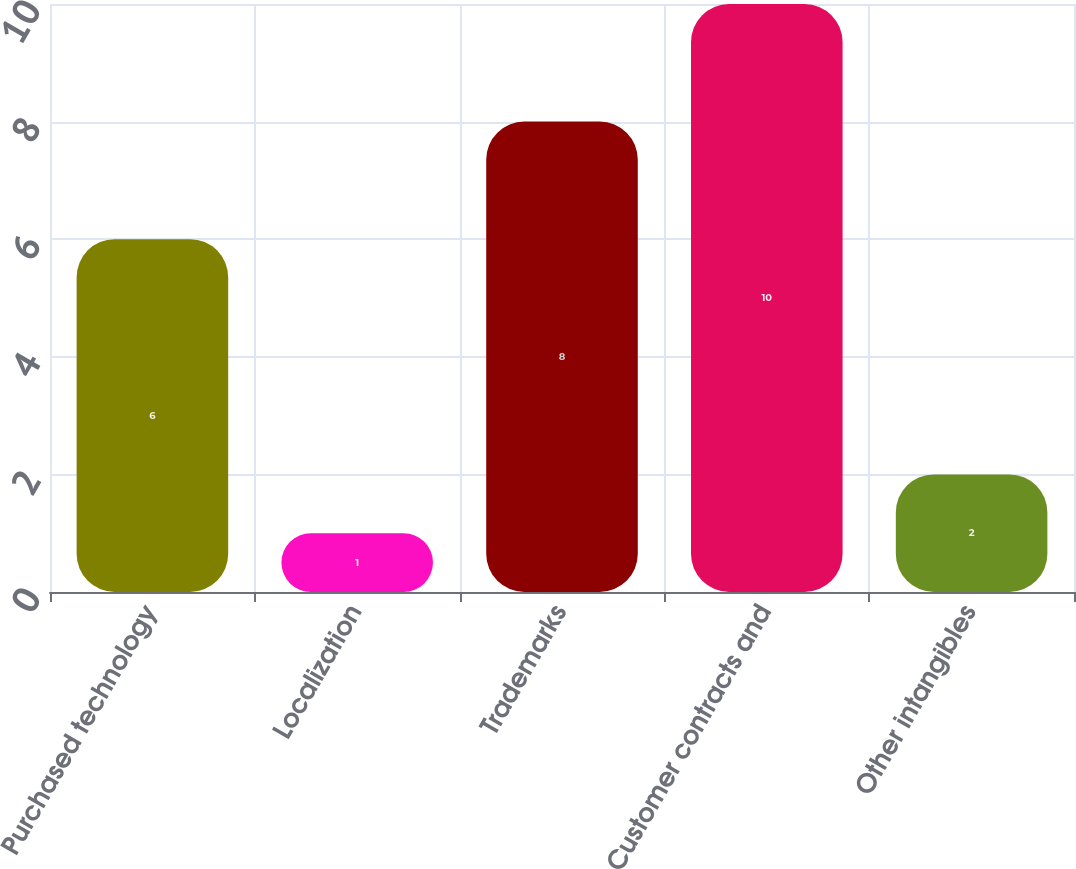Convert chart to OTSL. <chart><loc_0><loc_0><loc_500><loc_500><bar_chart><fcel>Purchased technology<fcel>Localization<fcel>Trademarks<fcel>Customer contracts and<fcel>Other intangibles<nl><fcel>6<fcel>1<fcel>8<fcel>10<fcel>2<nl></chart> 